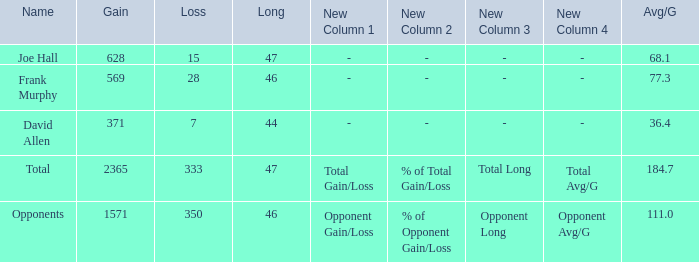Which Avg/G has a Name of david allen, and a Gain larger than 371? None. 